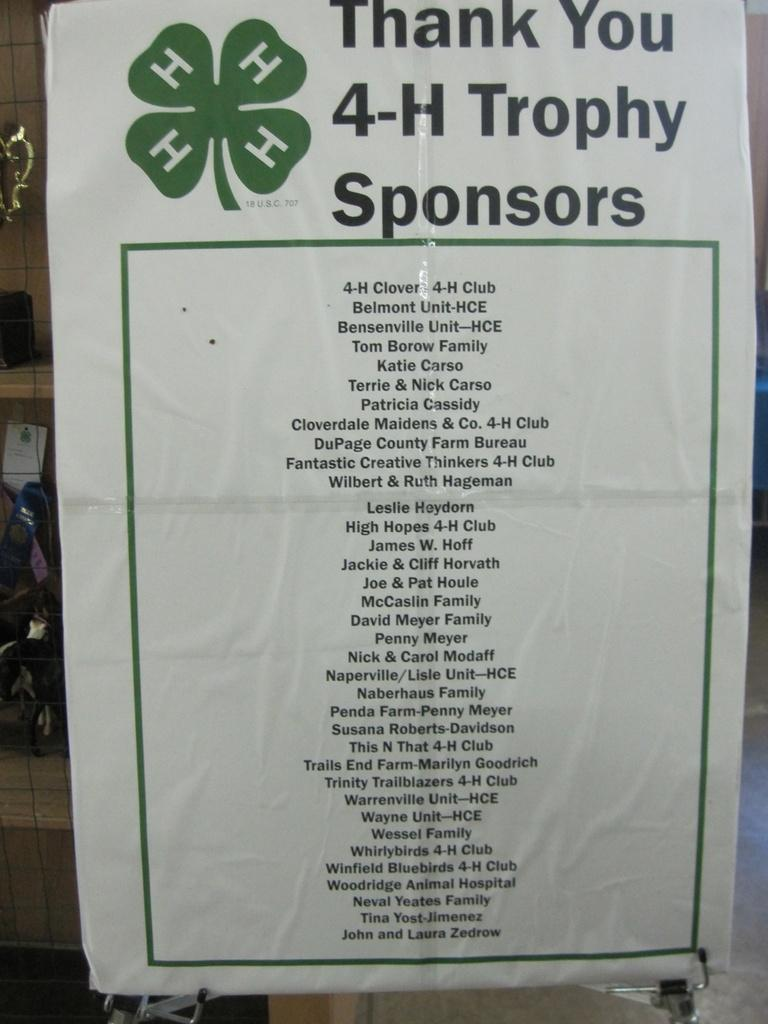<image>
Provide a brief description of the given image. a list of 4-h trophy sponsors written in black on a white sheet of paper 